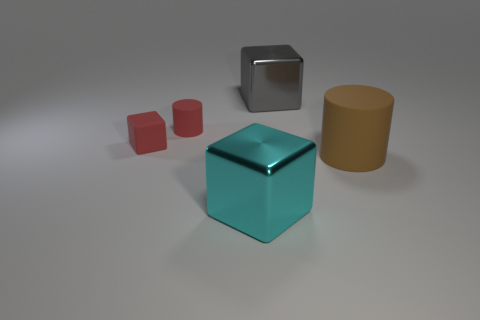Subtract all red cubes. How many cubes are left? 2 Add 1 brown things. How many objects exist? 6 Subtract all cubes. How many objects are left? 2 Subtract all green blocks. Subtract all green balls. How many blocks are left? 3 Subtract all tiny red matte cubes. Subtract all gray metal things. How many objects are left? 3 Add 3 red objects. How many red objects are left? 5 Add 3 small red rubber things. How many small red rubber things exist? 5 Subtract 0 purple spheres. How many objects are left? 5 